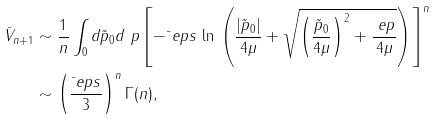Convert formula to latex. <formula><loc_0><loc_0><loc_500><loc_500>\bar { V } _ { n + 1 } & \sim \frac { 1 } { n } \int _ { 0 } d \tilde { p } _ { 0 } d \ p \left [ - \bar { \ } e p s \, \ln \, \left ( \frac { | \tilde { p } _ { 0 } | } { 4 \mu } + \sqrt { \left ( \frac { \tilde { p } _ { 0 } } { 4 \mu } \right ) ^ { 2 } + \frac { \ e p } { 4 \mu } } \right ) \right ] ^ { n } \\ & \sim \left ( \frac { \bar { \ } e p s } 3 \right ) ^ { n } \Gamma ( n ) ,</formula> 